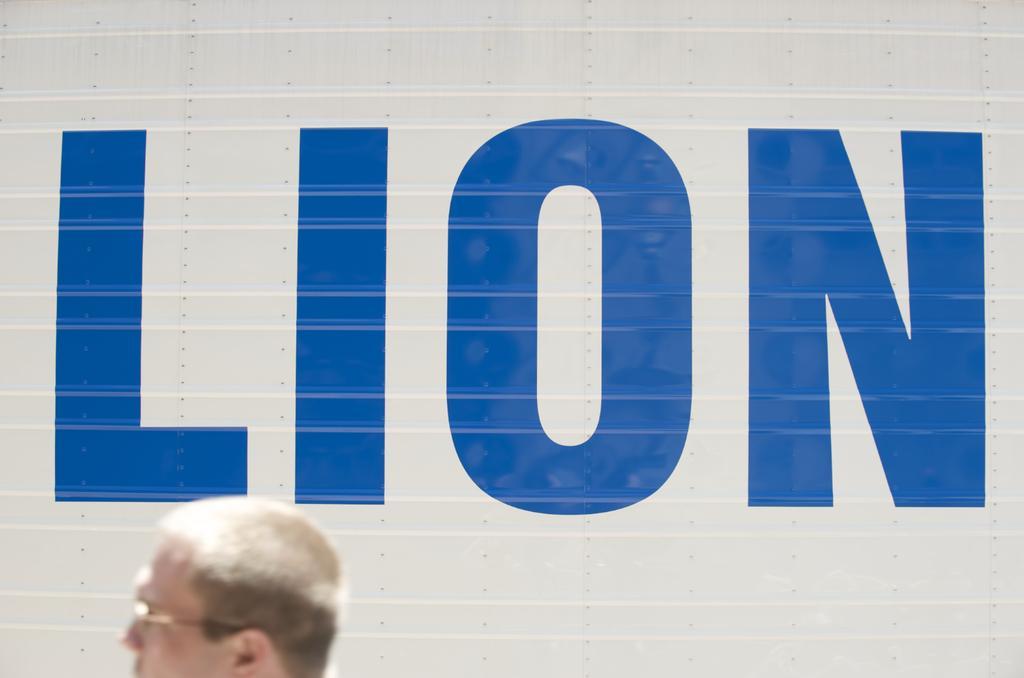Can you describe this image briefly? In this image we can see the head of a person. In the background, we can see some text on the surface. 